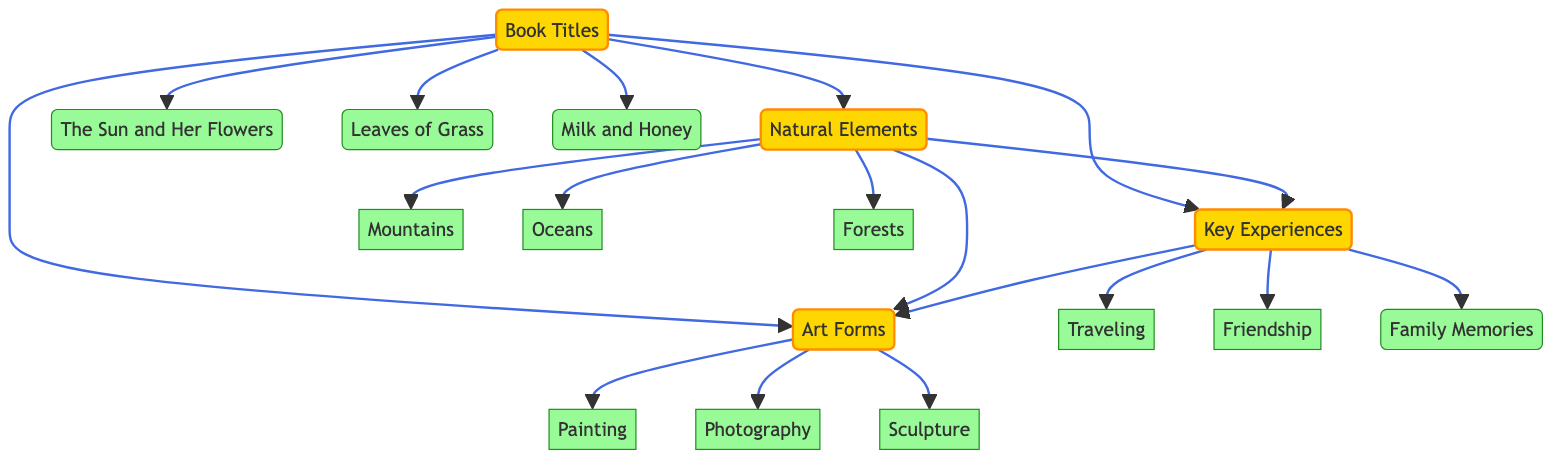What are the main sources of inspiration in this diagram? The diagram lists four main sources of inspiration: Books, Nature, Personal Experiences, and Art. These nodes are the first level of the diagram and are connected as source nodes.
Answer: Books, Nature, Personal Experiences, Art How many different book titles are shown? There are three book titles displayed under the Books node: The Sun and Her Flowers, Leaves of Grass, and Milk and Honey. Counting these child nodes will give the total number.
Answer: 3 What influences does Nature have, according to the diagram? Nature influences Personal Experiences and Art, as indicated by the directed edges leading from the Nature node to these two. This shows the relationships of influence in the diagram.
Answer: Personal Experiences, Art Which source has the most direct influences? Books is the source that has the most direct influences. It has directed edges leading to Nature, Personal Experiences, and Art, which indicates that it spurs ideas in those areas.
Answer: Books What kind of art forms are mentioned in the diagram? The diagram mentions three forms of art: Painting, Photography, and Sculpture. These are listed as child nodes under the Art node, indicating their relevance as sources of inspiration for poetry.
Answer: Painting, Photography, Sculpture What connection exists between Personal Experiences and Art? There is a directed edge from Personal Experiences to Art, which indicates that personal experiences influence artistic expression in this diagram. This relationship is shown by the arrows leading from one node to the other.
Answer: Personal Experiences to Art How many edges connect Books to other sources? Books has three outgoing edges connecting it to Nature, Personal Experiences, and Art. These edges represent the direct influences that books have on these other sources of inspiration. This can be counted by checking the outgoing links.
Answer: 3 Which natural element is included in the diagram? The diagram includes three natural elements: Mountains, Oceans, and Forests, listed under the Nature child nodes, indicating the types of nature that inspire poetry.
Answer: Mountains, Oceans, Forests What is the link between Nature and Personal Experiences? There is a directed edge from Nature to Personal Experiences, which signifies that experiences derived from nature can shape one's personal experiences, influencing the poetry created.
Answer: Nature to Personal Experiences Which source directly influences the most categories? Books directly influences three categories: Nature, Personal Experiences, and Art, making it the source that has the widest influence based on the connections shown in the diagram.
Answer: Books 